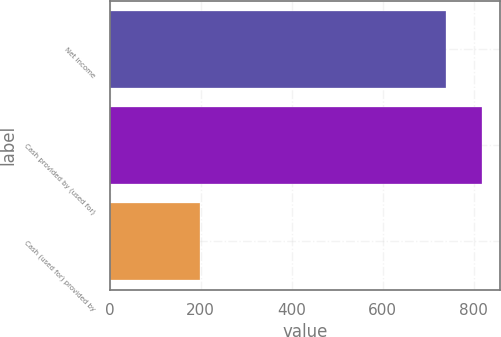Convert chart to OTSL. <chart><loc_0><loc_0><loc_500><loc_500><bar_chart><fcel>Net income<fcel>Cash provided by (used for)<fcel>Cash (used for) provided by<nl><fcel>740<fcel>818<fcel>198<nl></chart> 